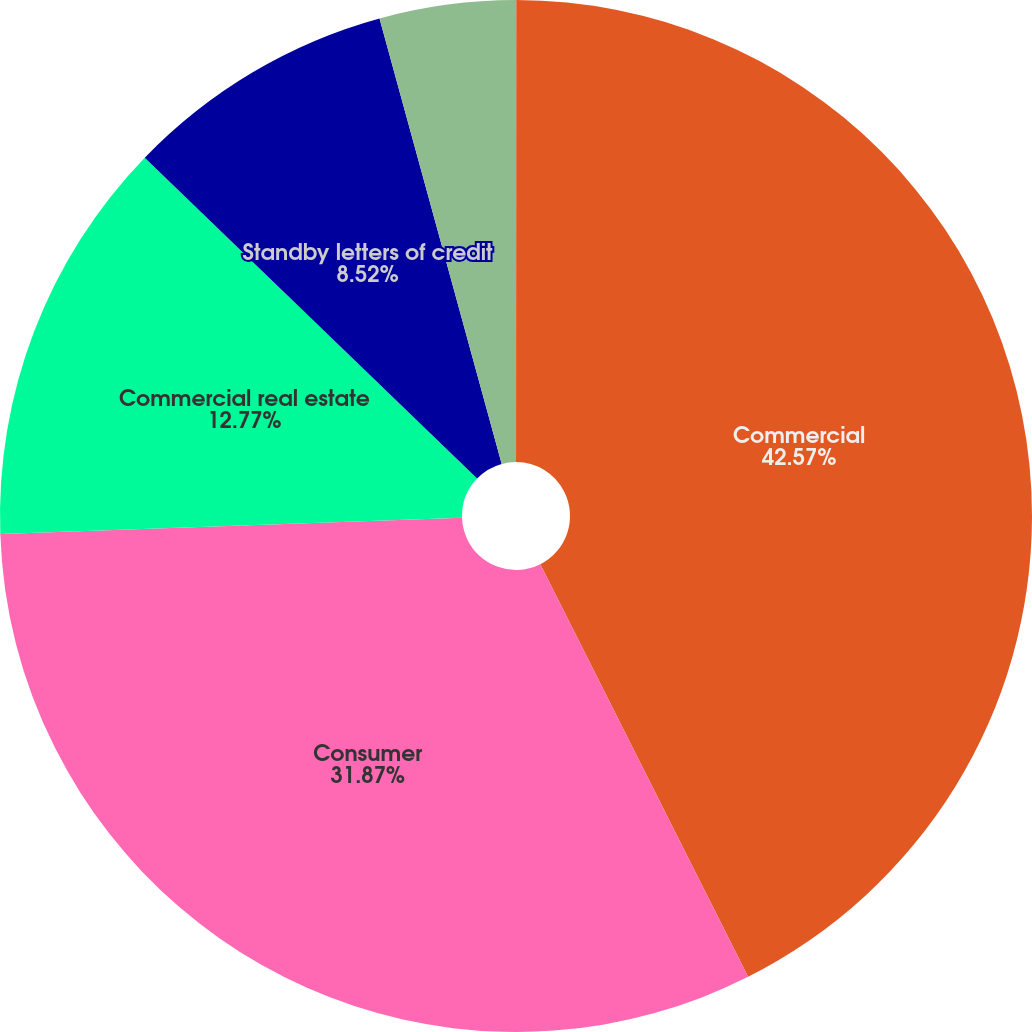Convert chart. <chart><loc_0><loc_0><loc_500><loc_500><pie_chart><fcel>(dollar amounts in thousands)<fcel>Commercial<fcel>Consumer<fcel>Commercial real estate<fcel>Standby letters of credit<fcel>Commercial letters-of-credit<nl><fcel>0.01%<fcel>42.56%<fcel>31.87%<fcel>12.77%<fcel>8.52%<fcel>4.26%<nl></chart> 